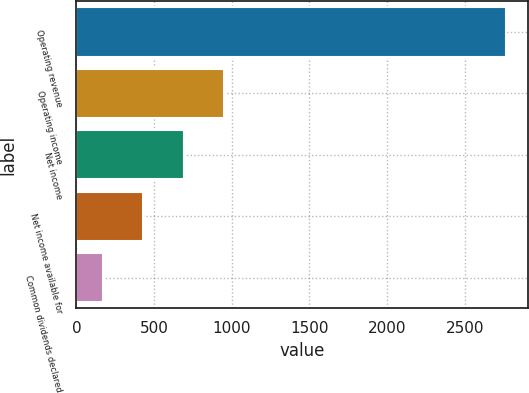Convert chart. <chart><loc_0><loc_0><loc_500><loc_500><bar_chart><fcel>Operating revenue<fcel>Operating income<fcel>Net income<fcel>Net income available for<fcel>Common dividends declared<nl><fcel>2768<fcel>949.4<fcel>689.6<fcel>429.8<fcel>170<nl></chart> 